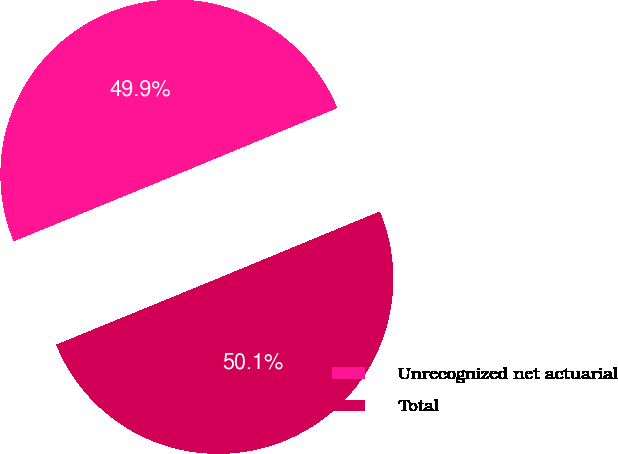Convert chart. <chart><loc_0><loc_0><loc_500><loc_500><pie_chart><fcel>Unrecognized net actuarial<fcel>Total<nl><fcel>49.94%<fcel>50.06%<nl></chart> 